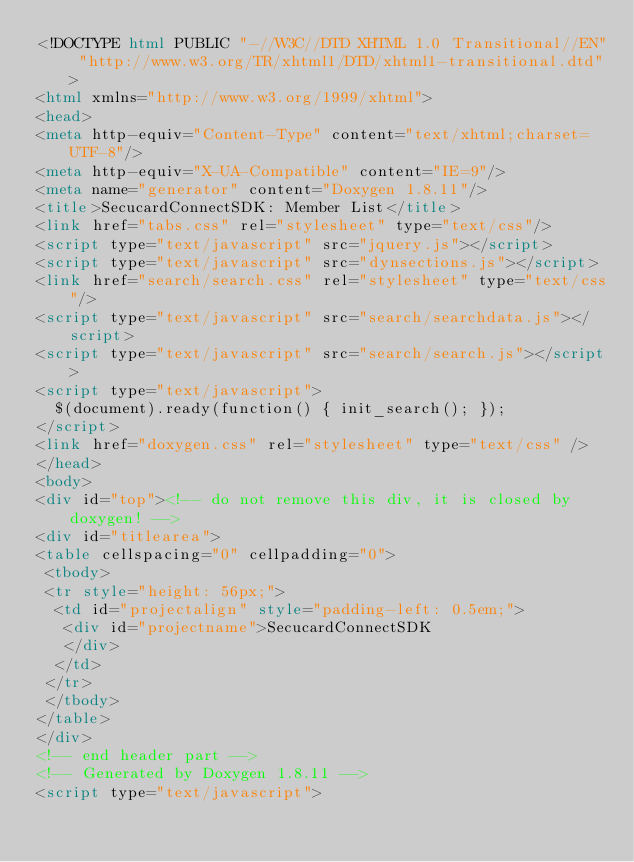Convert code to text. <code><loc_0><loc_0><loc_500><loc_500><_HTML_><!DOCTYPE html PUBLIC "-//W3C//DTD XHTML 1.0 Transitional//EN" "http://www.w3.org/TR/xhtml1/DTD/xhtml1-transitional.dtd">
<html xmlns="http://www.w3.org/1999/xhtml">
<head>
<meta http-equiv="Content-Type" content="text/xhtml;charset=UTF-8"/>
<meta http-equiv="X-UA-Compatible" content="IE=9"/>
<meta name="generator" content="Doxygen 1.8.11"/>
<title>SecucardConnectSDK: Member List</title>
<link href="tabs.css" rel="stylesheet" type="text/css"/>
<script type="text/javascript" src="jquery.js"></script>
<script type="text/javascript" src="dynsections.js"></script>
<link href="search/search.css" rel="stylesheet" type="text/css"/>
<script type="text/javascript" src="search/searchdata.js"></script>
<script type="text/javascript" src="search/search.js"></script>
<script type="text/javascript">
  $(document).ready(function() { init_search(); });
</script>
<link href="doxygen.css" rel="stylesheet" type="text/css" />
</head>
<body>
<div id="top"><!-- do not remove this div, it is closed by doxygen! -->
<div id="titlearea">
<table cellspacing="0" cellpadding="0">
 <tbody>
 <tr style="height: 56px;">
  <td id="projectalign" style="padding-left: 0.5em;">
   <div id="projectname">SecucardConnectSDK
   </div>
  </td>
 </tr>
 </tbody>
</table>
</div>
<!-- end header part -->
<!-- Generated by Doxygen 1.8.11 -->
<script type="text/javascript"></code> 